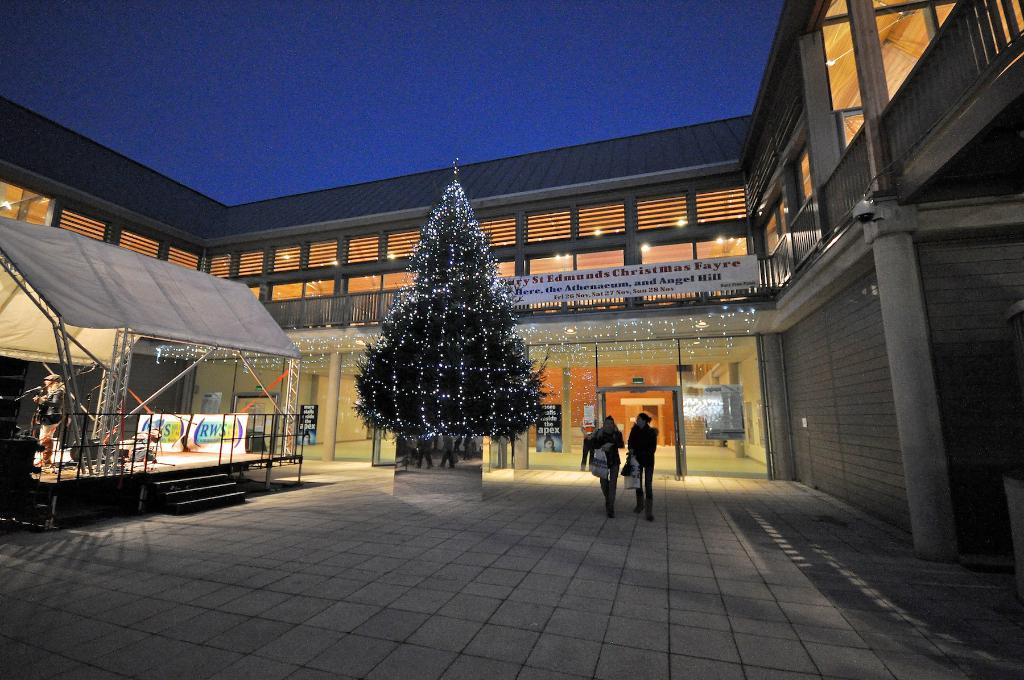What is the main subject in the center of the image? There is a Christmas tree and a shed in the center of the image. Are there any people present in the image? Yes, there are people in the center of the image. What can be seen in the background of the image? There is a building in the background of the image. How many geese are flying over the shed in the image? There are no geese present in the image. What type of clouds can be seen in the sky above the building in the background? There is no information about clouds in the image, as the sky is not mentioned in the provided facts. 